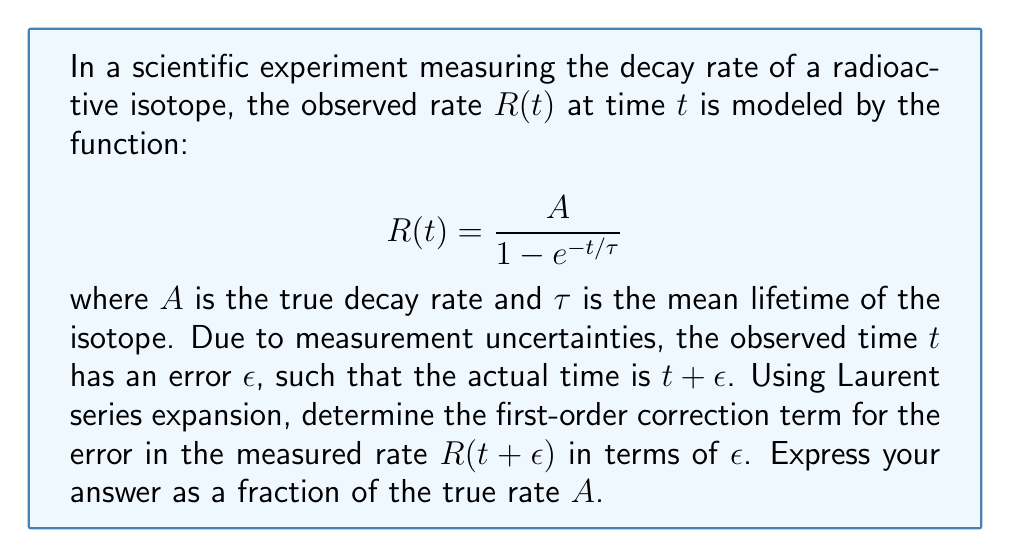Can you solve this math problem? To solve this problem, we'll follow these steps:

1) First, we need to find the Laurent series expansion of $R(t+\epsilon)$ around $\epsilon = 0$.

2) The Laurent series expansion of a function $f(z)$ around $z = a$ is given by:

   $$f(z) = \sum_{n=-\infty}^{\infty} c_n (z-a)^n$$

   where $c_n$ are the coefficients of the expansion.

3) In our case, we want to expand $R(t+\epsilon)$ around $\epsilon = 0$:

   $$R(t+\epsilon) = \frac{A}{1 - e^{-(t+\epsilon)/\tau}}$$

4) We can use the Taylor series expansion of $e^x$ around $x = 0$:

   $$e^x = 1 + x + \frac{x^2}{2!} + \frac{x^3}{3!} + ...$$

5) Substituting $x = -\epsilon/\tau$ in this expansion:

   $$e^{-\epsilon/\tau} = 1 - \frac{\epsilon}{\tau} + \frac{\epsilon^2}{2\tau^2} - ...$$

6) Now, our function becomes:

   $$R(t+\epsilon) = \frac{A}{1 - e^{-t/\tau}(1 - \frac{\epsilon}{\tau} + \frac{\epsilon^2}{2\tau^2} - ...)}$$

7) Using the binomial expansion $(1-x)^{-1} = 1 + x + x^2 + ...$, we get:

   $$R(t+\epsilon) = \frac{A}{1 - e^{-t/\tau}} \cdot (1 + e^{-t/\tau}(\frac{\epsilon}{\tau} - \frac{\epsilon^2}{2\tau^2}) + ...)$$

8) Multiplying out and keeping only terms up to first order in $\epsilon$:

   $$R(t+\epsilon) \approx \frac{A}{1 - e^{-t/\tau}} + \frac{A e^{-t/\tau}}{(1 - e^{-t/\tau})^2} \cdot \frac{\epsilon}{\tau}$$

9) The first term is just $R(t)$, so the error term (first-order correction) is:

   $$\frac{A e^{-t/\tau}}{(1 - e^{-t/\tau})^2} \cdot \frac{\epsilon}{\tau}$$

10) To express this as a fraction of the true rate $A$, we divide by $A$:

    $$\frac{e^{-t/\tau}}{(1 - e^{-t/\tau})^2} \cdot \frac{\epsilon}{\tau}$$
Answer: $\frac{e^{-t/\tau}}{(1 - e^{-t/\tau})^2} \cdot \frac{\epsilon}{\tau}$ 